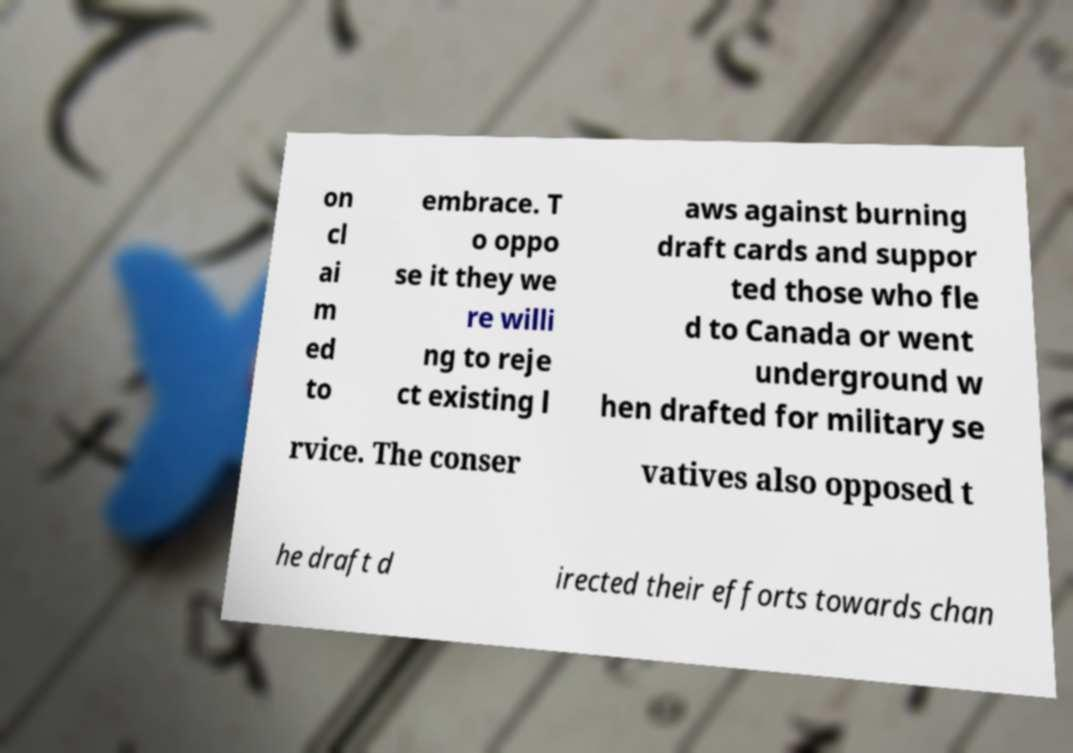Could you extract and type out the text from this image? on cl ai m ed to embrace. T o oppo se it they we re willi ng to reje ct existing l aws against burning draft cards and suppor ted those who fle d to Canada or went underground w hen drafted for military se rvice. The conser vatives also opposed t he draft d irected their efforts towards chan 